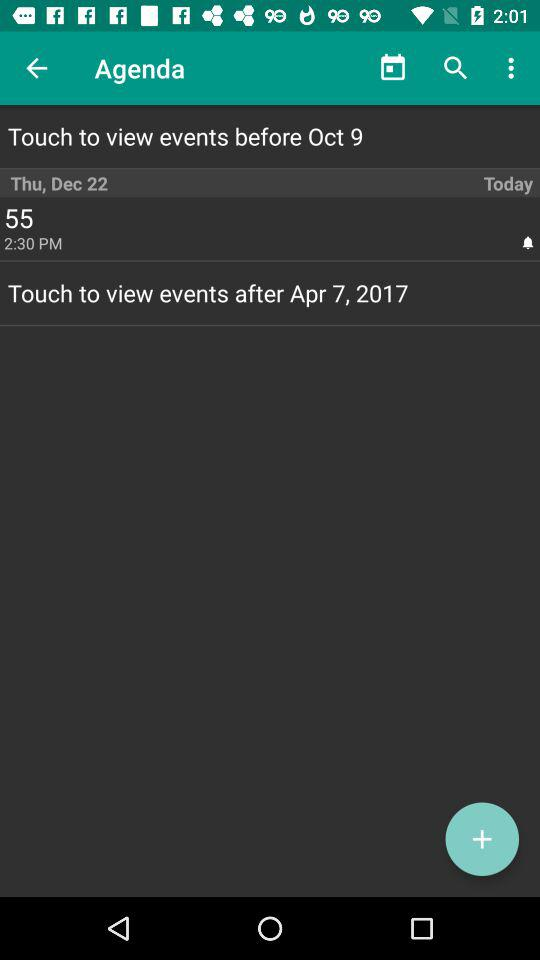What date is written after "Touch to view events"? The date that is written after "Touch to view events" is April 7, 2017. 